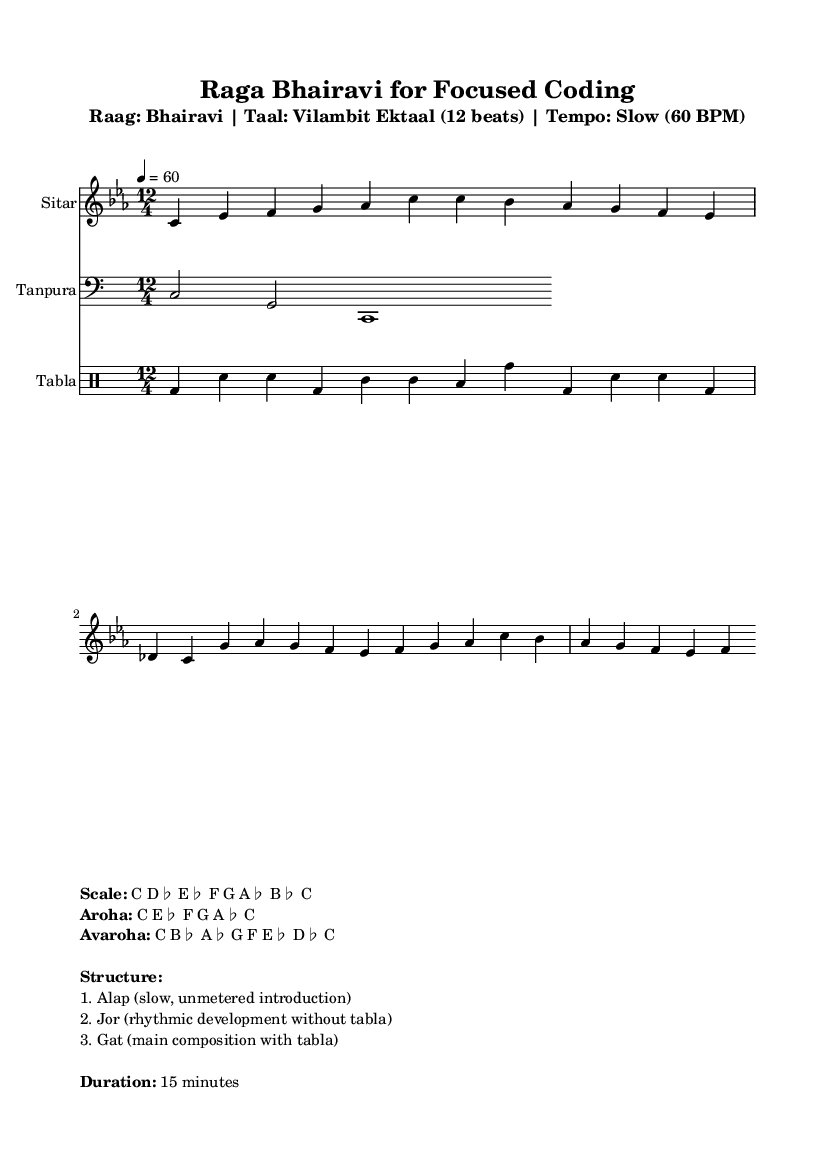What is the key signature of this music? The key signature is C minor, which has three flat notes (B♭, E♭, and A♭). This can be identified from the “\key c \minor” notation in the code.
Answer: C minor What is the time signature of this music? The time signature is 12/4, indicating there are 12 beats per measure. This is shown in the “\time 12/4” notation in the code.
Answer: 12/4 What is the tempo marking of this piece? The tempo is marked as slow, set at 60 beats per minute (BPM). This is noted in the tempo section of the code: “Tempo: Slow (60 BPM)”.
Answer: 60 What is the name of the featured raga in this music? The name of the featured raga is Bhairavi, as indicated in the title of the header: “Raga Bhairavi for Focused Coding”.
Answer: Bhairavi What are the first two notes of the melody? The first two notes in the melody are C and E♭. This can be derived from the first part of the melody part in the code, where "c4 es" appears.
Answer: C, E♭ How is the structure of the performance categorized? The structure of the performance is categorized into three parts: Alap, Jor, and Gat. This information is detailed in the markup section under "Structure:" in the code.
Answer: Alap, Jor, Gat What type of composition is this music based on the context provided? This music is a traditional composition of Indian classical music, specifically under the category of ragas meant for deep concentration and focus. This distinction can be inferred from the setting and the raga mentioned.
Answer: Traditional Indian classical music 